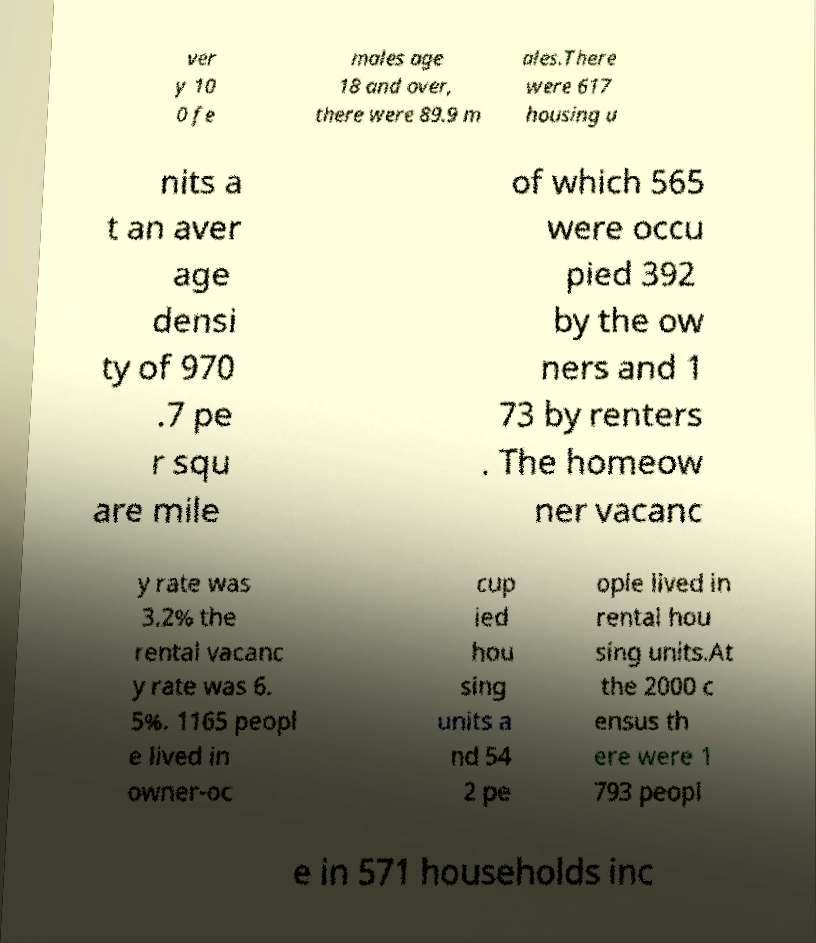What messages or text are displayed in this image? I need them in a readable, typed format. ver y 10 0 fe males age 18 and over, there were 89.9 m ales.There were 617 housing u nits a t an aver age densi ty of 970 .7 pe r squ are mile of which 565 were occu pied 392 by the ow ners and 1 73 by renters . The homeow ner vacanc y rate was 3.2% the rental vacanc y rate was 6. 5%. 1165 peopl e lived in owner-oc cup ied hou sing units a nd 54 2 pe ople lived in rental hou sing units.At the 2000 c ensus th ere were 1 793 peopl e in 571 households inc 